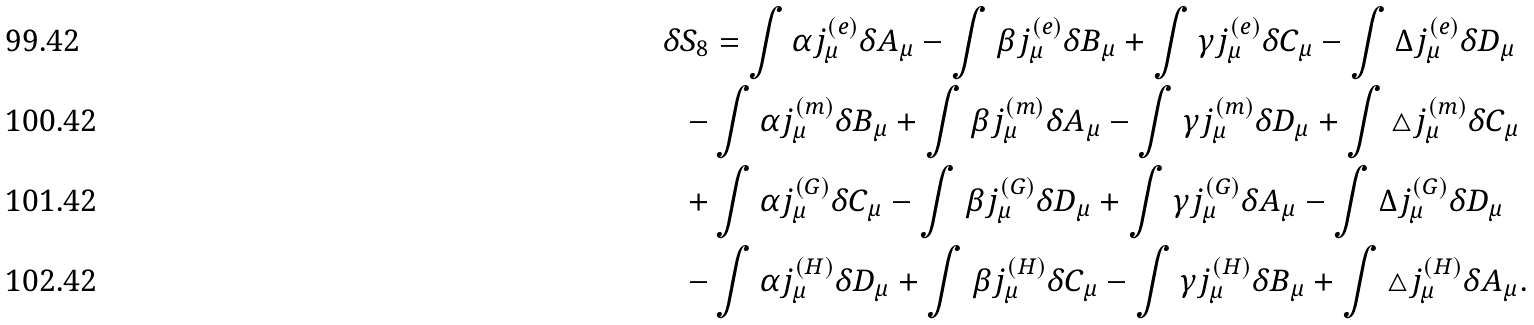Convert formula to latex. <formula><loc_0><loc_0><loc_500><loc_500>\delta S _ { 8 } & = \int \alpha j _ { \mu } ^ { ( e ) } \delta A _ { \mu } - \int \beta j _ { \mu } ^ { ( e ) } \delta B _ { \mu } + \int \gamma j _ { \mu } ^ { ( e ) } \delta C _ { \mu } - \int \Delta j _ { \mu } ^ { ( e ) } \delta D _ { \mu } \\ - & \int \alpha j _ { \mu } ^ { ( m ) } \delta B _ { \mu } + \int \beta j _ { \mu } ^ { ( m ) } \delta A _ { \mu } - \int \gamma j _ { \mu } ^ { ( m ) } \delta D _ { \mu } + \int \triangle j _ { \mu } ^ { ( m ) } \delta C _ { \mu } \\ + & \int \alpha j _ { \mu } ^ { ( G ) } \delta C _ { \mu } - \int \beta j _ { \mu } ^ { ( G ) } \delta D _ { \mu } + \int \gamma j _ { \mu } ^ { ( G ) } \delta A _ { \mu } - \int \Delta j _ { \mu } ^ { ( G ) } \delta D _ { \mu } \\ - & \int \alpha j _ { \mu } ^ { ( H ) } \delta D _ { \mu } + \int \beta j _ { \mu } ^ { ( H ) } \delta C _ { \mu } - \int \gamma j _ { \mu } ^ { ( H ) } \delta B _ { \mu } + \int \triangle j _ { \mu } ^ { ( H ) } \delta A _ { \mu } .</formula> 